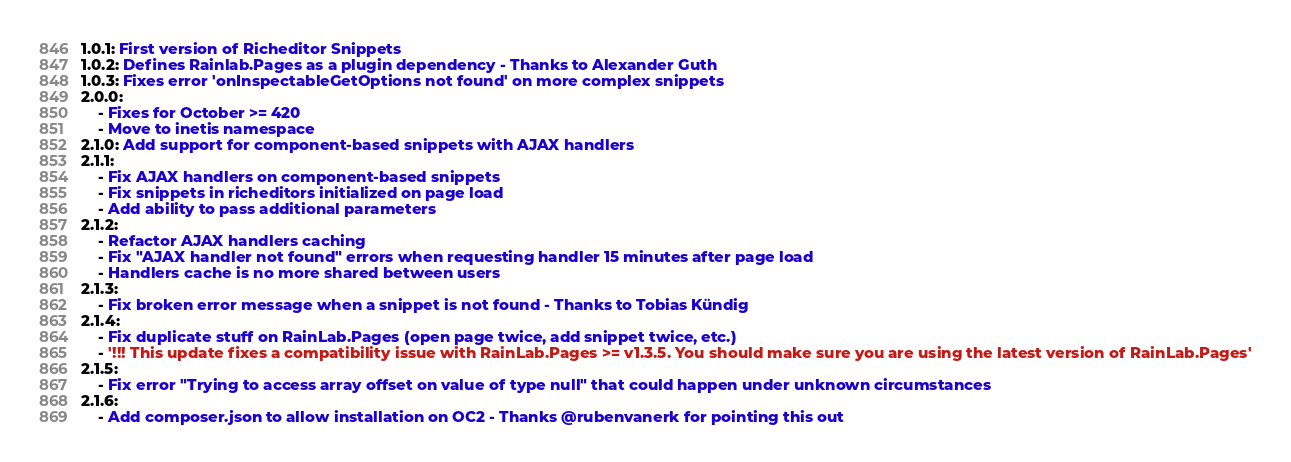<code> <loc_0><loc_0><loc_500><loc_500><_YAML_>1.0.1: First version of Richeditor Snippets
1.0.2: Defines Rainlab.Pages as a plugin dependency - Thanks to Alexander Guth
1.0.3: Fixes error 'onInspectableGetOptions not found' on more complex snippets
2.0.0:
    - Fixes for October >= 420
    - Move to inetis namespace
2.1.0: Add support for component-based snippets with AJAX handlers
2.1.1:
    - Fix AJAX handlers on component-based snippets
    - Fix snippets in richeditors initialized on page load
    - Add ability to pass additional parameters
2.1.2:
    - Refactor AJAX handlers caching
    - Fix "AJAX handler not found" errors when requesting handler 15 minutes after page load
    - Handlers cache is no more shared between users
2.1.3:
    - Fix broken error message when a snippet is not found - Thanks to Tobias Kündig
2.1.4:
    - Fix duplicate stuff on RainLab.Pages (open page twice, add snippet twice, etc.)
    - '!!! This update fixes a compatibility issue with RainLab.Pages >= v1.3.5. You should make sure you are using the latest version of RainLab.Pages'
2.1.5:
    - Fix error "Trying to access array offset on value of type null" that could happen under unknown circumstances
2.1.6:
    - Add composer.json to allow installation on OC2 - Thanks @rubenvanerk for pointing this out
</code> 